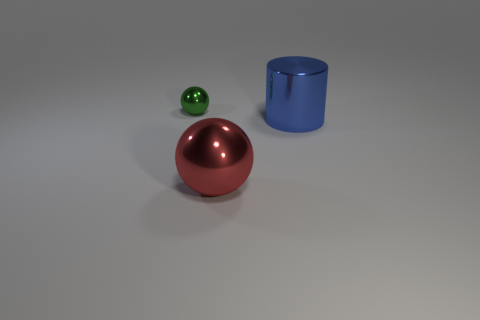Add 3 gray rubber things. How many objects exist? 6 Subtract all balls. How many objects are left? 1 Add 2 green metallic things. How many green metallic things are left? 3 Add 2 large green shiny blocks. How many large green shiny blocks exist? 2 Subtract 0 brown balls. How many objects are left? 3 Subtract all small purple spheres. Subtract all blue cylinders. How many objects are left? 2 